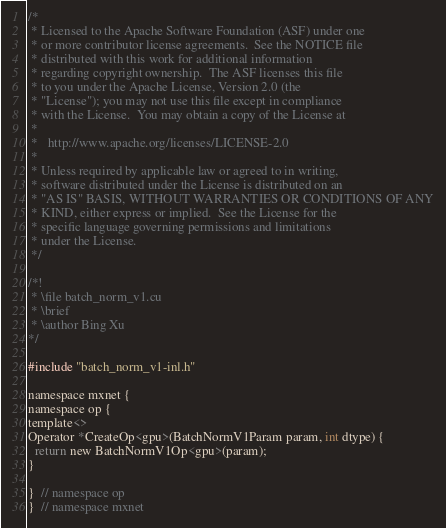Convert code to text. <code><loc_0><loc_0><loc_500><loc_500><_Cuda_>/*
 * Licensed to the Apache Software Foundation (ASF) under one
 * or more contributor license agreements.  See the NOTICE file
 * distributed with this work for additional information
 * regarding copyright ownership.  The ASF licenses this file
 * to you under the Apache License, Version 2.0 (the
 * "License"); you may not use this file except in compliance
 * with the License.  You may obtain a copy of the License at
 *
 *   http://www.apache.org/licenses/LICENSE-2.0
 *
 * Unless required by applicable law or agreed to in writing,
 * software distributed under the License is distributed on an
 * "AS IS" BASIS, WITHOUT WARRANTIES OR CONDITIONS OF ANY
 * KIND, either express or implied.  See the License for the
 * specific language governing permissions and limitations
 * under the License.
 */

/*!
 * \file batch_norm_v1.cu
 * \brief
 * \author Bing Xu
*/

#include "batch_norm_v1-inl.h"

namespace mxnet {
namespace op {
template<>
Operator *CreateOp<gpu>(BatchNormV1Param param, int dtype) {
  return new BatchNormV1Op<gpu>(param);
}

}  // namespace op
}  // namespace mxnet

</code> 